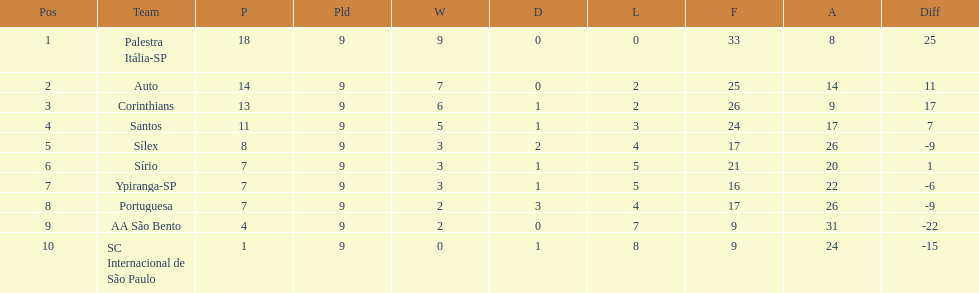Which brazilian team secured the first place in the 1926 brazilian football cup? Palestra Itália-SP. 